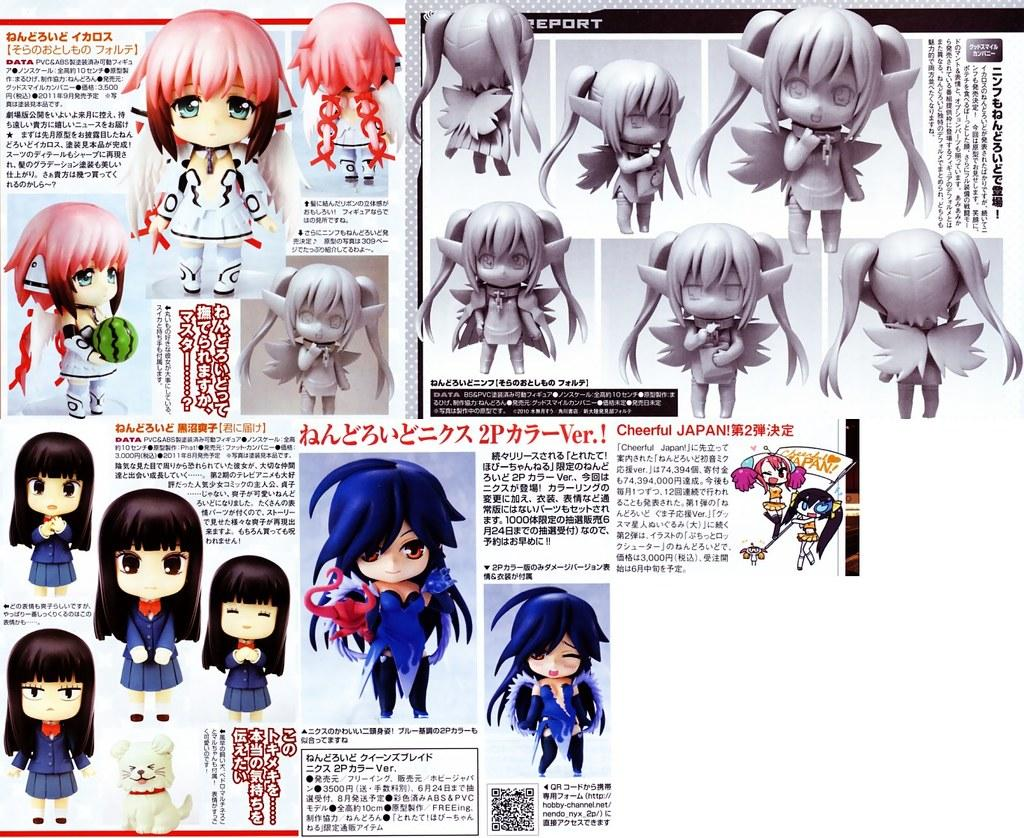What type of visual is the image? The image is a poster. What can be found on the poster? There are paragraphs on the poster. What else is depicted on the poster besides text? There are toys depicted on the poster. What type of polish is being advertised on the poster? There is no polish being advertised on the poster; it features paragraphs and toys. Can you provide an example of a toy depicted on the poster? It is not possible to provide an example of a toy depicted on the poster without referring to the image directly. 